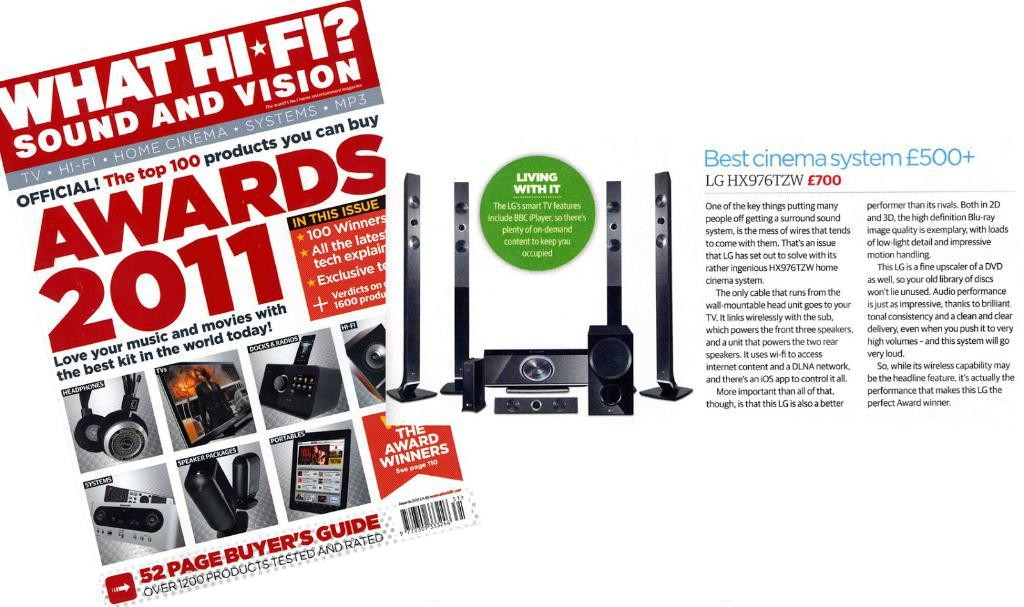<image>
Describe the image concisely. An article has the best cinema system for 500 pounds and up. 